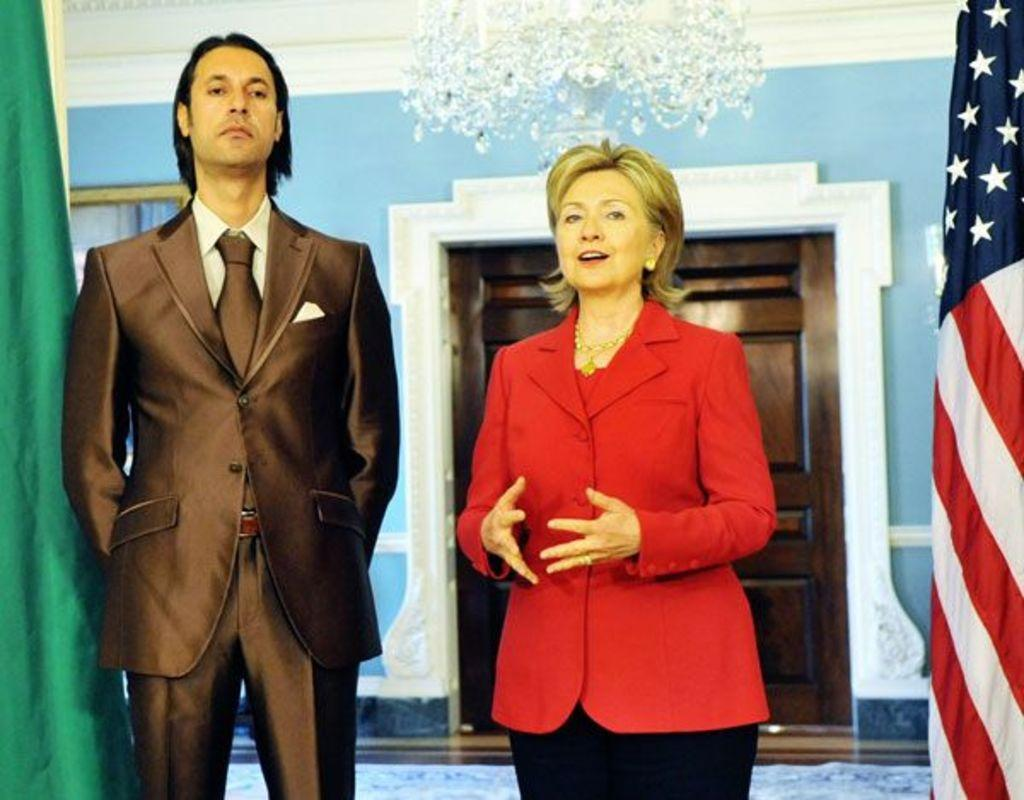Who are the people in the image? There is a man and a woman standing in the image. What is the man wearing? The man is wearing a suit. What can be seen on the right side of the image? There is a flag on the right side of the image. What architectural feature is visible in the background of the image? There is a door visible in the background of the image. How many boys are hiding behind the bushes in the image? There are no boys or bushes present in the image. 